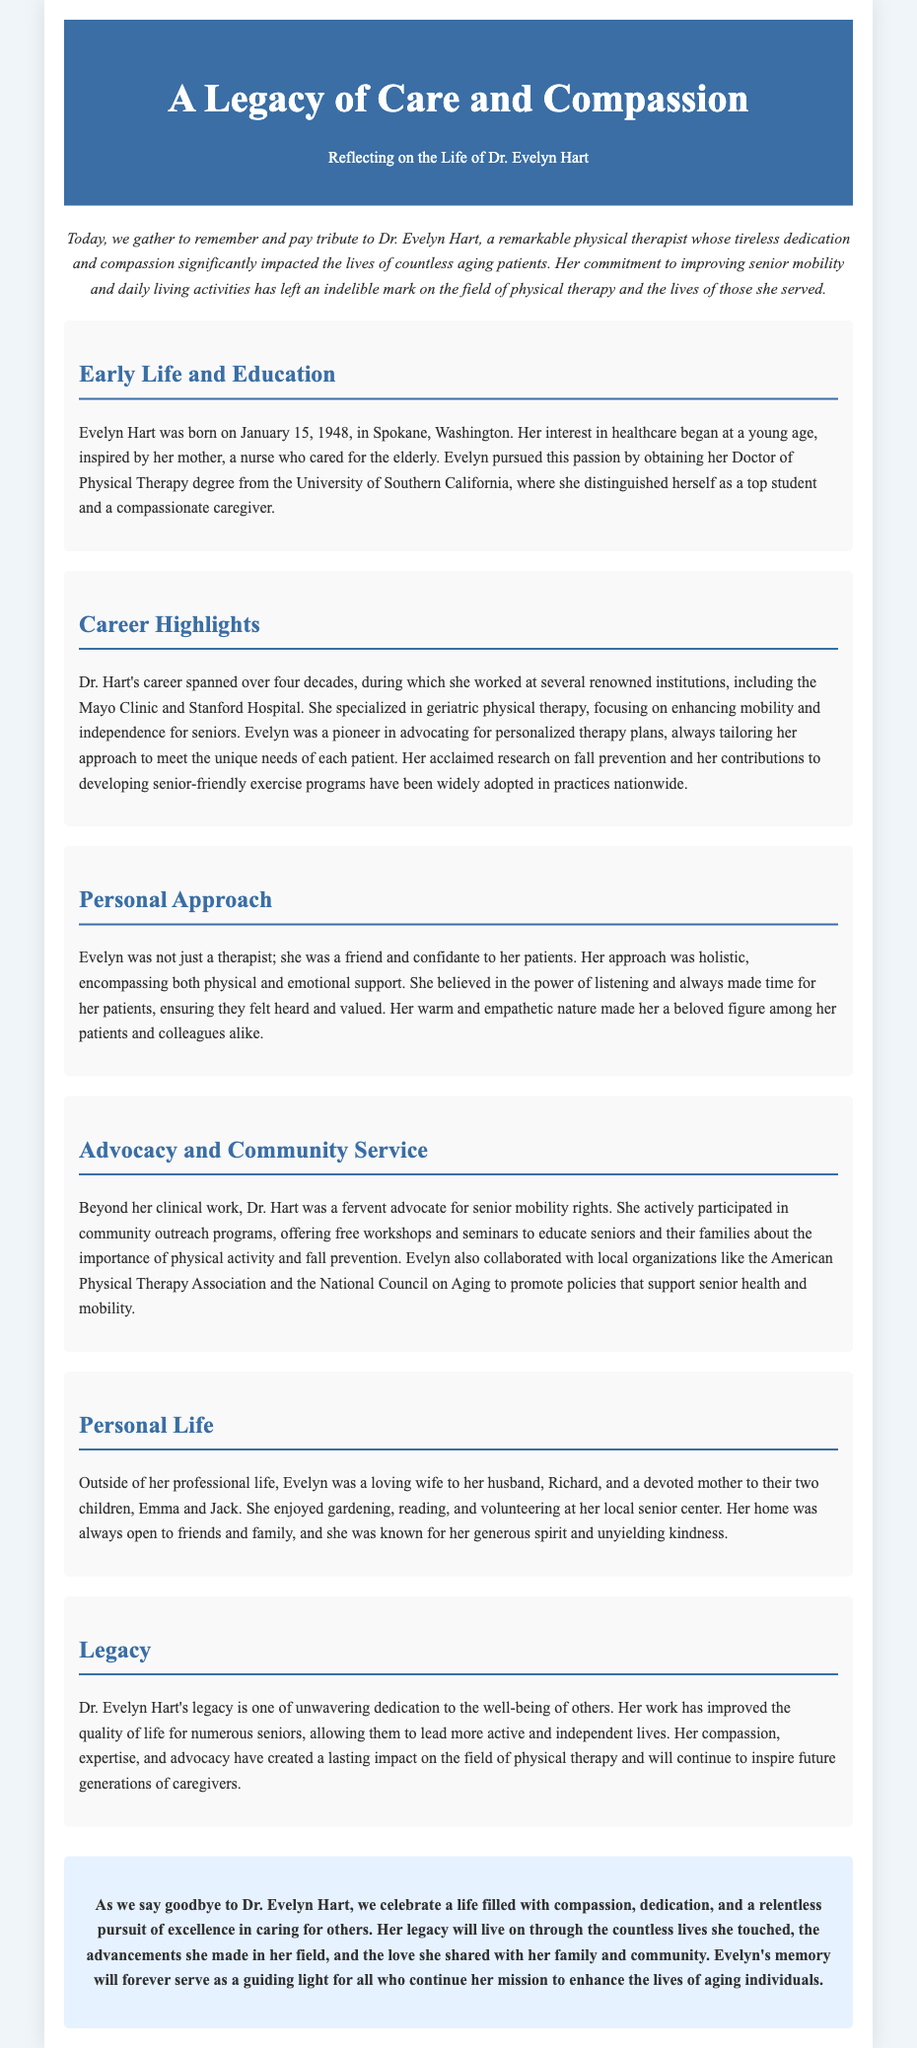What is Dr. Evelyn Hart's profession? The document indicates that Dr. Evelyn Hart was a physical therapist.
Answer: physical therapist When was Dr. Evelyn Hart born? According to the document, Evelyn Hart was born on January 15, 1948.
Answer: January 15, 1948 Which universities did Dr. Hart attend? The document states that she obtained her Doctor of Physical Therapy degree from the University of Southern California.
Answer: University of Southern California What was Dr. Hart's specialization? The document highlights that she specialized in geriatric physical therapy.
Answer: geriatric physical therapy What was one of Dr. Hart's significant contributions? The document mentions her research on fall prevention as a significant contribution to the field.
Answer: research on fall prevention What approach did Dr. Hart take towards her therapy? The document describes her approach as holistic, encompassing both physical and emotional support.
Answer: holistic What type of community service did Dr. Hart engage in? The document notes that she offered free workshops and seminars for senior health and mobility education.
Answer: workshops and seminars Who was Dr. Hart's spouse? The document refers to her spouse as Richard.
Answer: Richard What year did Dr. Hart’s career span from? The document states that her career spanned over four decades, beginning in the late 1970s.
Answer: late 1970s What does Dr. Hart's legacy focus on? According to the document, her legacy focuses on unwavering dedication to the well-being of others.
Answer: well-being of others 